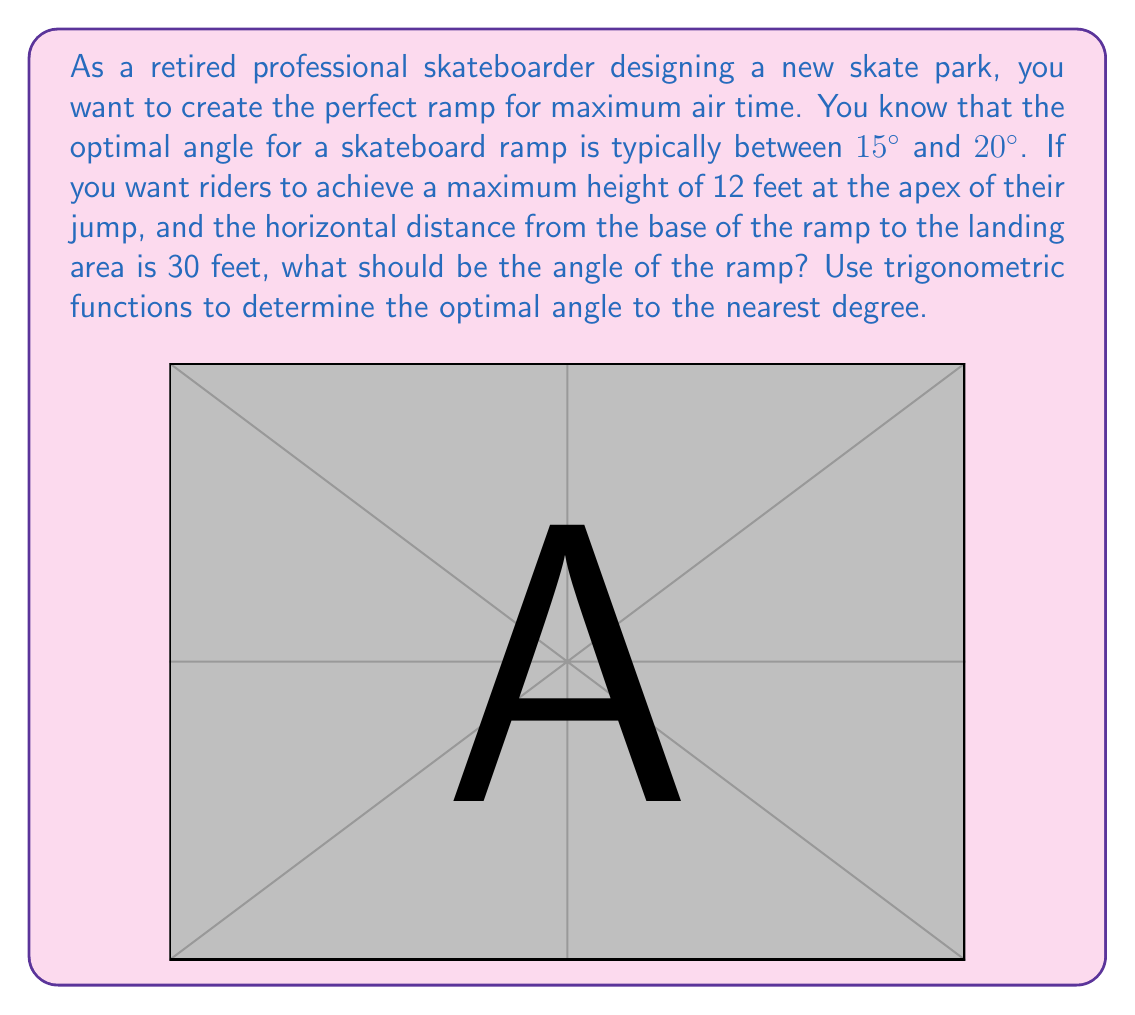Could you help me with this problem? Let's approach this step-by-step using trigonometric functions:

1) In this scenario, we have a right triangle where:
   - The adjacent side (horizontal distance) is 30 feet
   - The opposite side (maximum height) is 12 feet
   - We need to find the angle $\theta$

2) The trigonometric function that relates the opposite side to the adjacent side is the tangent function:

   $$\tan(\theta) = \frac{\text{opposite}}{\text{adjacent}} = \frac{\text{height}}{\text{horizontal distance}}$$

3) Substituting our known values:

   $$\tan(\theta) = \frac{12}{30} = \frac{2}{5} = 0.4$$

4) To find $\theta$, we need to use the inverse tangent function (arctan or $\tan^{-1}$):

   $$\theta = \tan^{-1}(0.4)$$

5) Using a calculator or computer:

   $$\theta \approx 21.80^\circ$$

6) Rounding to the nearest degree:

   $$\theta \approx 22^\circ$$

7) This result is slightly higher than the typical optimal range (15° to 20°), but it's the angle required for the given height and distance. It's within a reasonable range for an extreme sports ramp.
Answer: The optimal angle for the ramp is approximately $22^\circ$. 